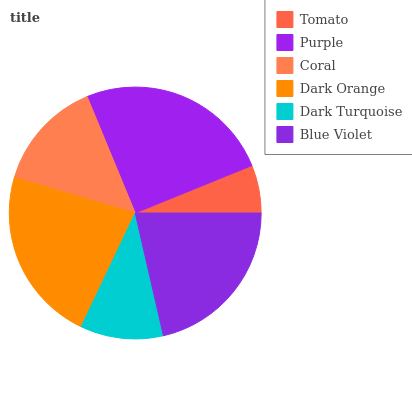Is Tomato the minimum?
Answer yes or no. Yes. Is Purple the maximum?
Answer yes or no. Yes. Is Coral the minimum?
Answer yes or no. No. Is Coral the maximum?
Answer yes or no. No. Is Purple greater than Coral?
Answer yes or no. Yes. Is Coral less than Purple?
Answer yes or no. Yes. Is Coral greater than Purple?
Answer yes or no. No. Is Purple less than Coral?
Answer yes or no. No. Is Blue Violet the high median?
Answer yes or no. Yes. Is Coral the low median?
Answer yes or no. Yes. Is Tomato the high median?
Answer yes or no. No. Is Dark Orange the low median?
Answer yes or no. No. 